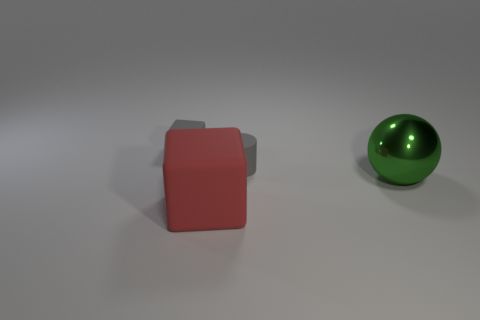How many other things are there of the same size as the rubber cylinder?
Your answer should be compact. 1. Is the color of the large sphere the same as the small cylinder?
Your answer should be very brief. No. Is there anything else that is the same material as the tiny gray cylinder?
Keep it short and to the point. Yes. Is the material of the tiny cylinder the same as the tiny gray object on the left side of the large matte object?
Your answer should be compact. Yes. What is the shape of the small object that is to the right of the matte block that is in front of the metal sphere?
Your response must be concise. Cylinder. How many small objects are red cubes or green rubber things?
Keep it short and to the point. 0. What number of other red rubber things are the same shape as the red object?
Your answer should be compact. 0. There is a large rubber thing; does it have the same shape as the tiny gray thing that is in front of the gray cube?
Give a very brief answer. No. There is a small block; how many gray cubes are left of it?
Your answer should be compact. 0. Is there another gray cylinder that has the same size as the gray cylinder?
Keep it short and to the point. No. 